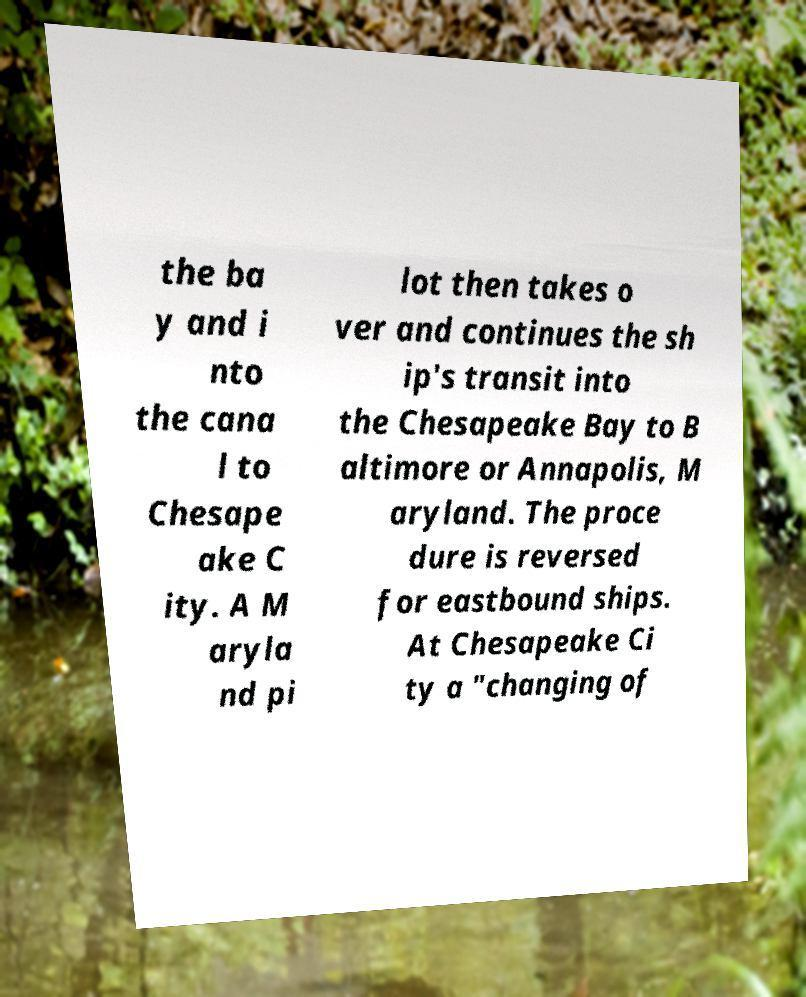Could you extract and type out the text from this image? the ba y and i nto the cana l to Chesape ake C ity. A M aryla nd pi lot then takes o ver and continues the sh ip's transit into the Chesapeake Bay to B altimore or Annapolis, M aryland. The proce dure is reversed for eastbound ships. At Chesapeake Ci ty a "changing of 